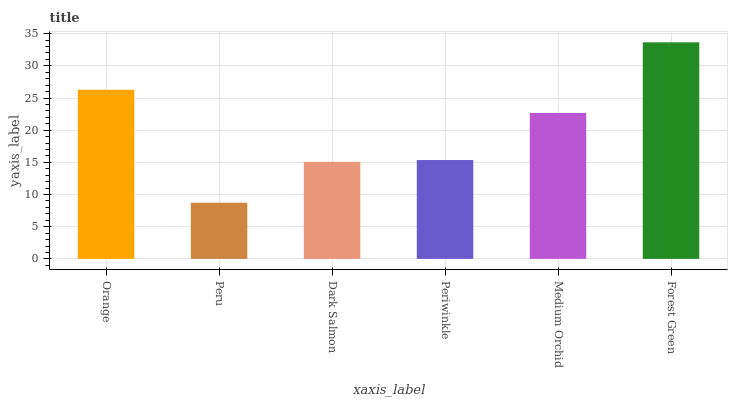Is Peru the minimum?
Answer yes or no. Yes. Is Forest Green the maximum?
Answer yes or no. Yes. Is Dark Salmon the minimum?
Answer yes or no. No. Is Dark Salmon the maximum?
Answer yes or no. No. Is Dark Salmon greater than Peru?
Answer yes or no. Yes. Is Peru less than Dark Salmon?
Answer yes or no. Yes. Is Peru greater than Dark Salmon?
Answer yes or no. No. Is Dark Salmon less than Peru?
Answer yes or no. No. Is Medium Orchid the high median?
Answer yes or no. Yes. Is Periwinkle the low median?
Answer yes or no. Yes. Is Peru the high median?
Answer yes or no. No. Is Dark Salmon the low median?
Answer yes or no. No. 